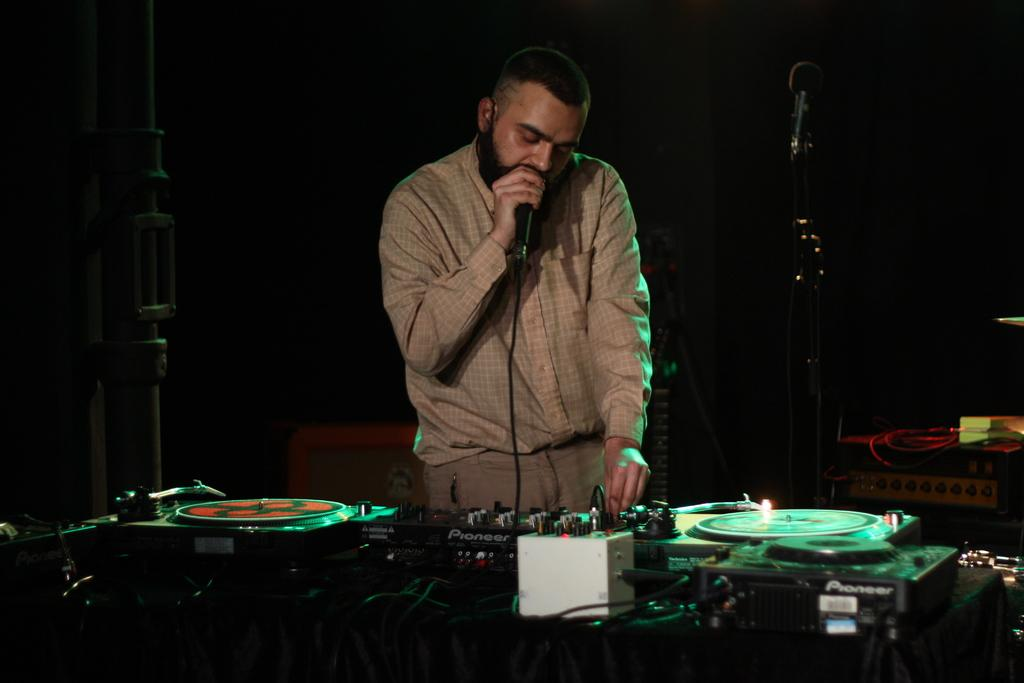What is the man in the image doing? The man is standing in the image and holding a microphone in his hand. What objects are in front of the man? There are electrical devices in front of the man. What is the color of the background in the image? The background of the image is black. Can you see any injuries on the man's knee in the image? There is no mention of the man's knee or any injuries in the provided facts, so we cannot answer this question based on the image. 